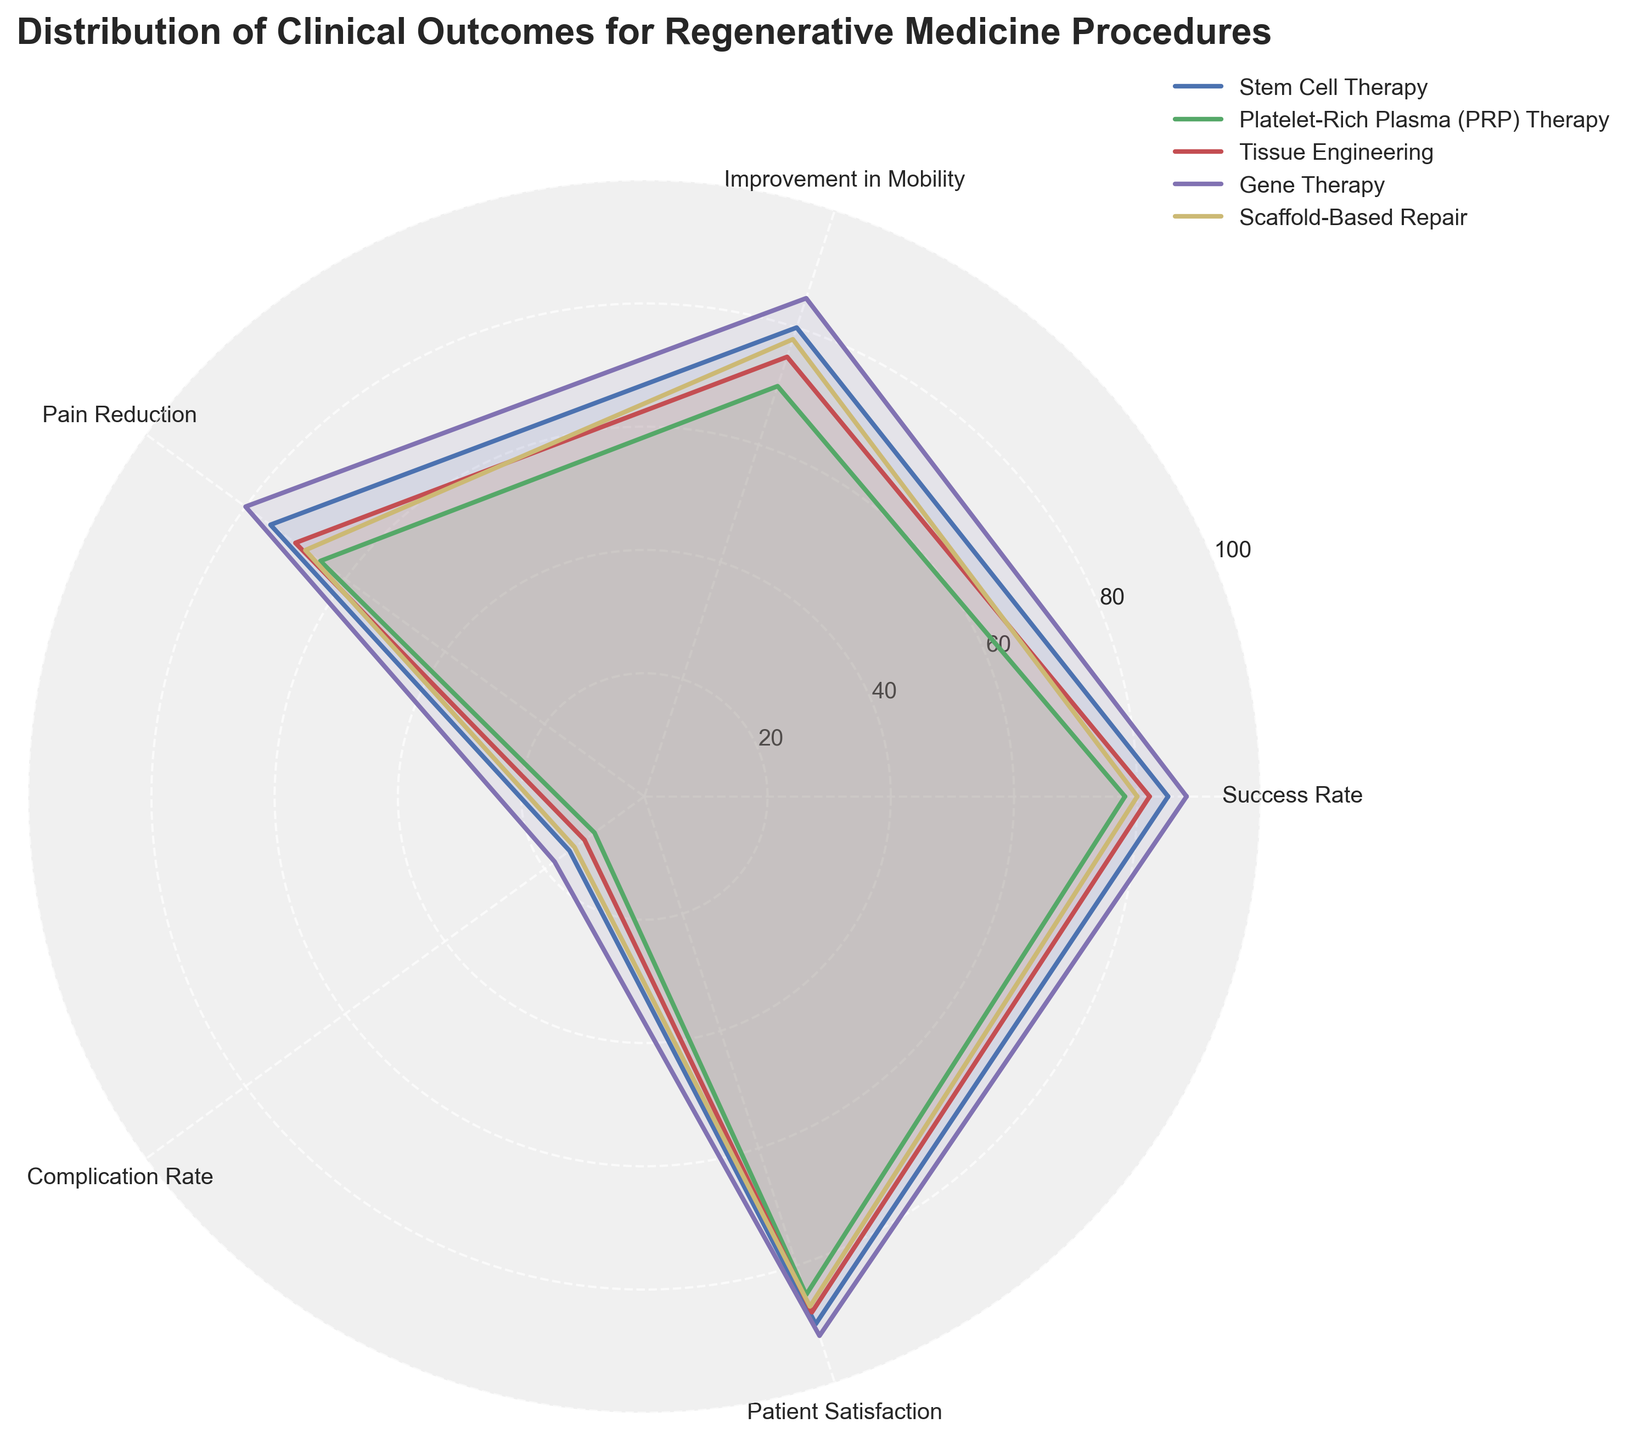What is the title of the chart? The title is usually displayed at the top of the chart. It gives an overview of what the chart is about. In this case, the title is "Distribution of Clinical Outcomes for Regenerative Medicine Procedures".
Answer: Distribution of Clinical Outcomes for Regenerative Medicine Procedures Which procedure has the highest success rate? To find the procedure with the highest success rate, look at the values on the radar chart corresponding to Success Rate and identify which line extends the furthest. Gene Therapy has the highest success rate at 88%.
Answer: Gene Therapy What is the Complication Rate for Platelet-Rich Plasma (PRP) Therapy? To find this, locate the section labeled "Complication Rate" on the radar chart and find the corresponding value for Platelet-Rich Plasma (PRP) Therapy. It is represented by the PRP line intersecting the Complication Rate axis. The value is 10%.
Answer: 10% Which procedure shows the lowest Improvement in Mobility? Find the "Improvement in Mobility" section on the radar chart and compare the values for each procedure. Platelet-Rich Plasma (PRP) Therapy has the lowest Improvement in Mobility at 70%.
Answer: Platelet-Rich Plasma (PRP) Therapy What is the average Patient Satisfaction across all procedures? To calculate this, first find the Patient Satisfaction values for all procedures: 90, 85, 88, 92, and 87. Then sum these values and divide by the number of procedures. (90 + 85 + 88 + 92 + 87) / 5 = 88.4
Answer: 88.4 Which procedure has the highest value for Pain Reduction? Find the "Pain Reduction" section on the radar chart and compare the lengths of the lines. The highest value, 80%, is associated with Gene Therapy.
Answer: Gene Therapy How does Scaffold-Based Repair compare to Tissue Engineering in terms of Complication Rate? Compare the Complication Rate values for Scaffold-Based Repair and Tissue Engineering. Scaffold-Based Repair has a value of 14%, and Tissue Engineering has a value of 12%. Scaffold-Based Repair has a higher complication rate.
Answer: Scaffold-Based Repair has a higher complication rate Which procedure has the highest combined score for Success Rate and Patient Satisfaction? Add the Success Rate and Patient Satisfaction values for each procedure and identify the highest total. Gene Therapy: 88 + 92 = 180. Stem Cell Therapy: 85 + 90 = 175. Scaffold-Based Repair: 80 + 87 = 167. Tissue Engineering: 82 + 88 = 170. Platelet-Rich Plasma: 78 + 85 = 163. Gene Therapy has the highest combined score of 180.
Answer: Gene Therapy 